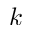<formula> <loc_0><loc_0><loc_500><loc_500>k</formula> 